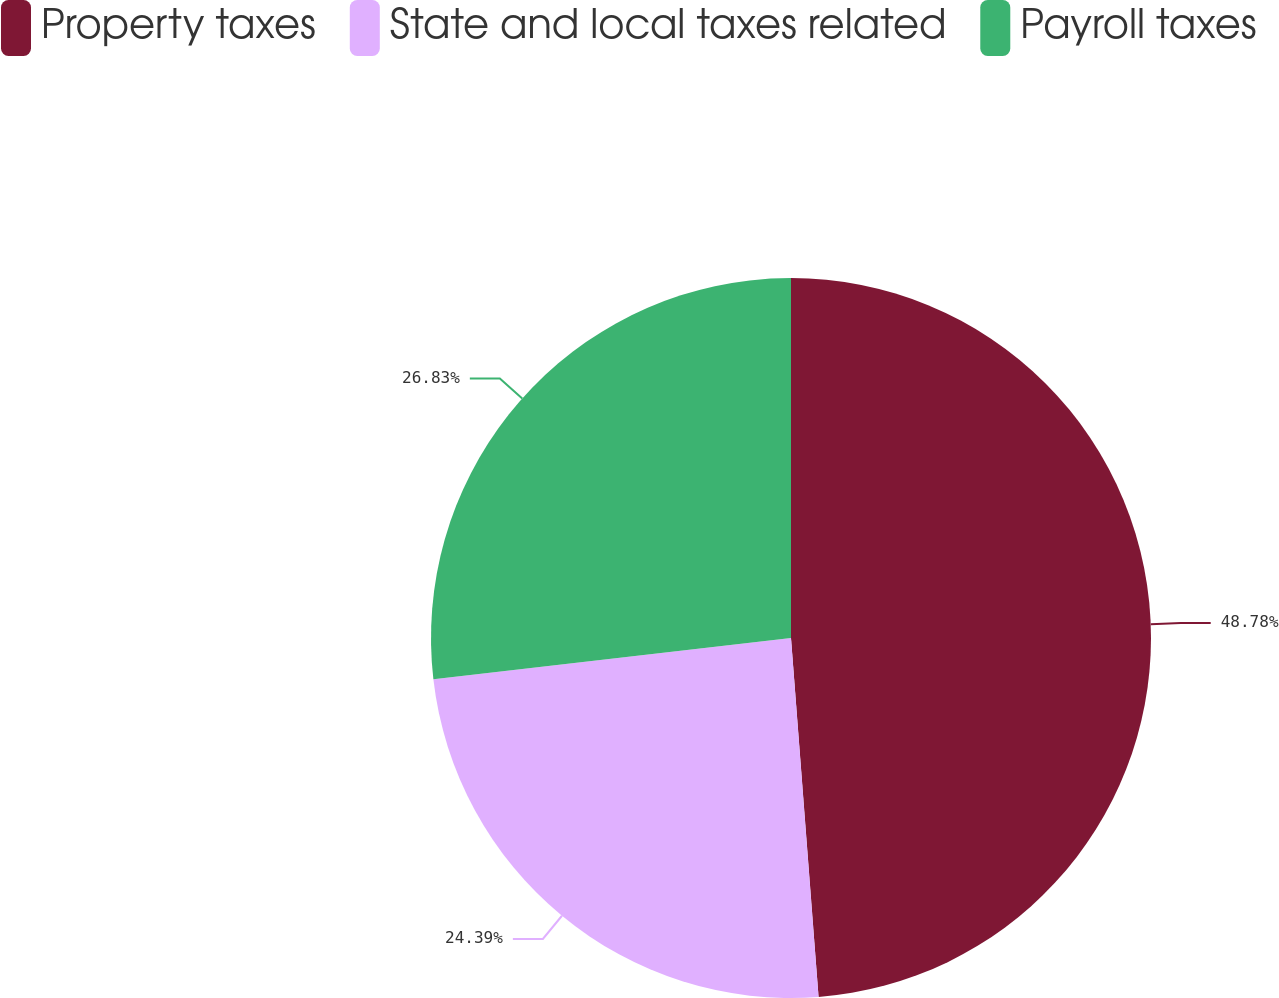<chart> <loc_0><loc_0><loc_500><loc_500><pie_chart><fcel>Property taxes<fcel>State and local taxes related<fcel>Payroll taxes<nl><fcel>48.78%<fcel>24.39%<fcel>26.83%<nl></chart> 